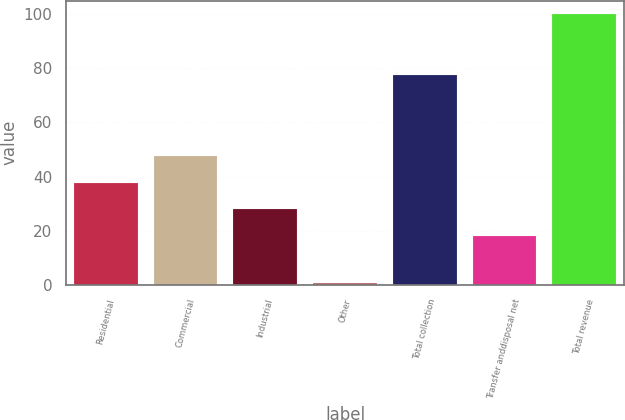Convert chart. <chart><loc_0><loc_0><loc_500><loc_500><bar_chart><fcel>Residential<fcel>Commercial<fcel>Industrial<fcel>Other<fcel>Total collection<fcel>Transfer anddisposal net<fcel>Total revenue<nl><fcel>37.76<fcel>47.69<fcel>27.83<fcel>0.7<fcel>77.7<fcel>17.9<fcel>100<nl></chart> 